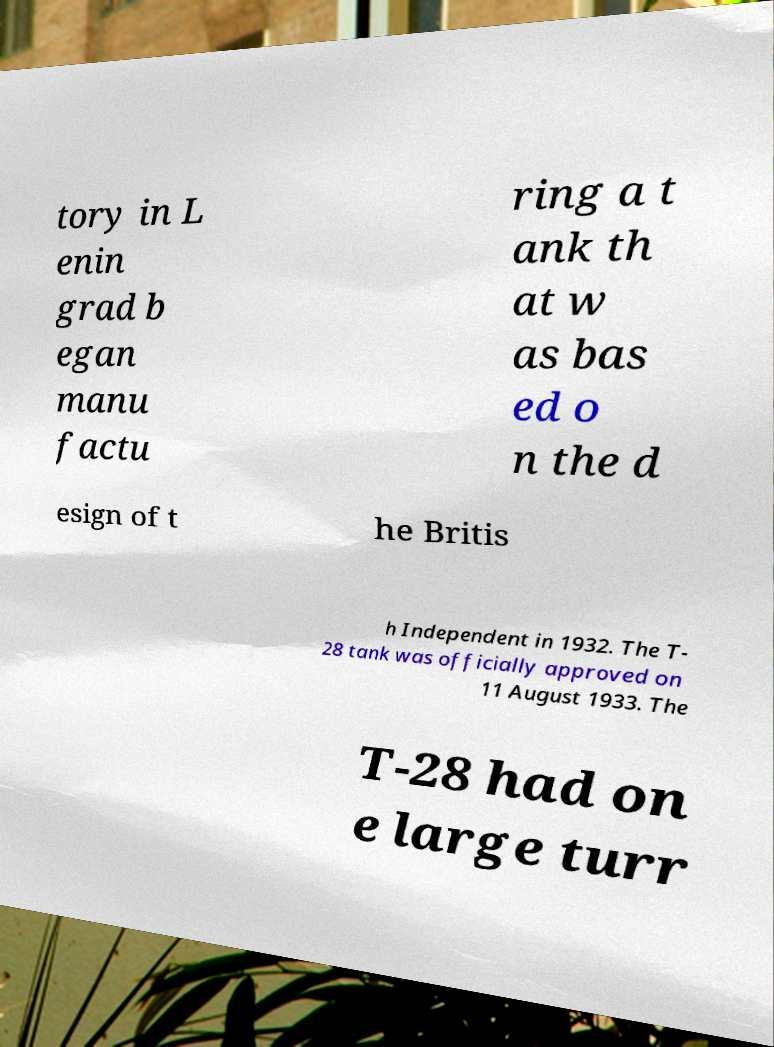Please read and relay the text visible in this image. What does it say? tory in L enin grad b egan manu factu ring a t ank th at w as bas ed o n the d esign of t he Britis h Independent in 1932. The T- 28 tank was officially approved on 11 August 1933. The T-28 had on e large turr 